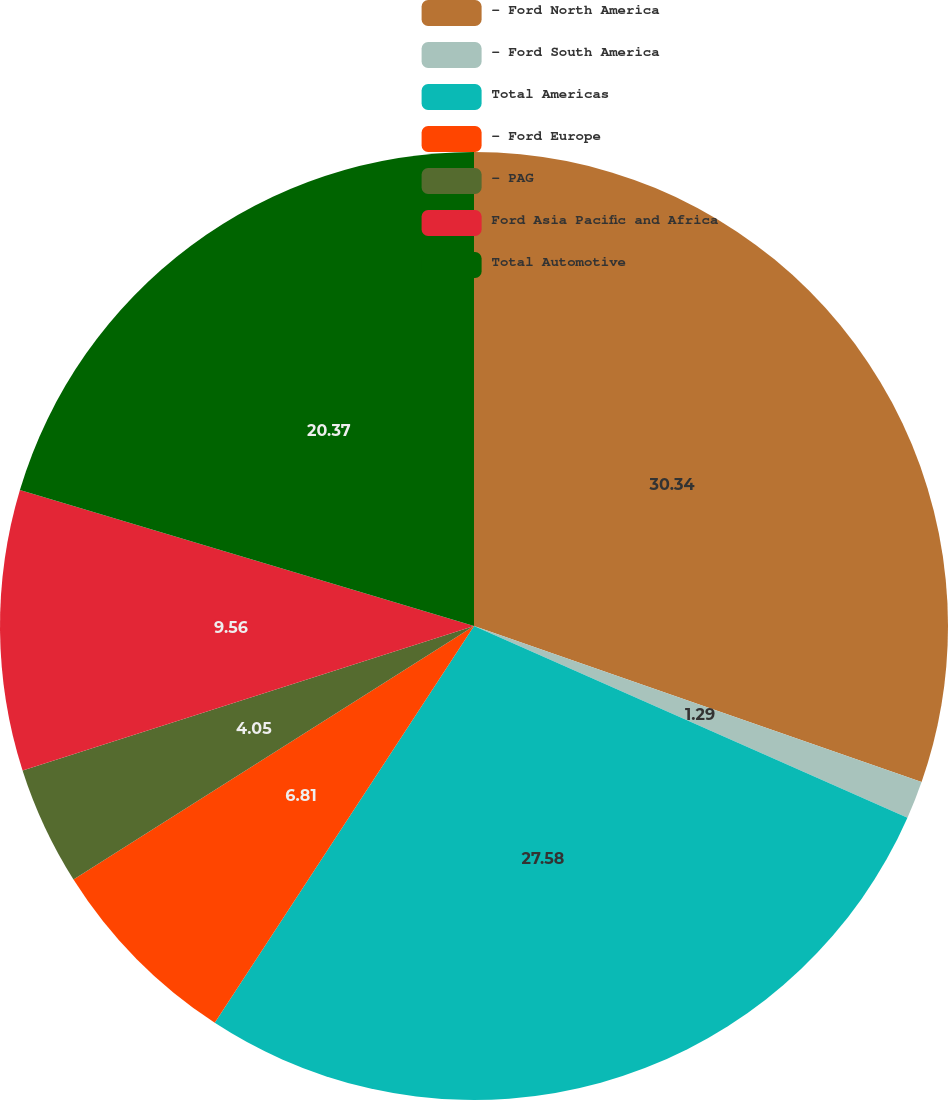Convert chart. <chart><loc_0><loc_0><loc_500><loc_500><pie_chart><fcel>- Ford North America<fcel>- Ford South America<fcel>Total Americas<fcel>- Ford Europe<fcel>- PAG<fcel>Ford Asia Pacific and Africa<fcel>Total Automotive<nl><fcel>30.34%<fcel>1.29%<fcel>27.58%<fcel>6.81%<fcel>4.05%<fcel>9.56%<fcel>20.37%<nl></chart> 